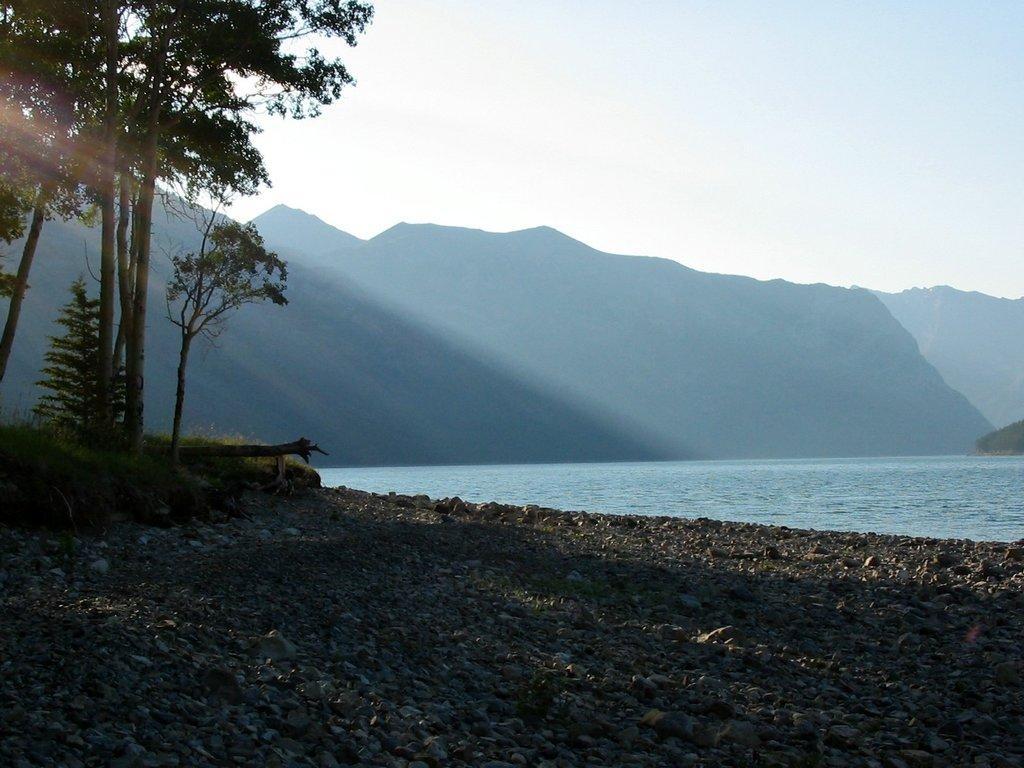Could you give a brief overview of what you see in this image? In the picture I can see few rocks and there are few trees and plants in the left corner and there is water and mountains in the background. 